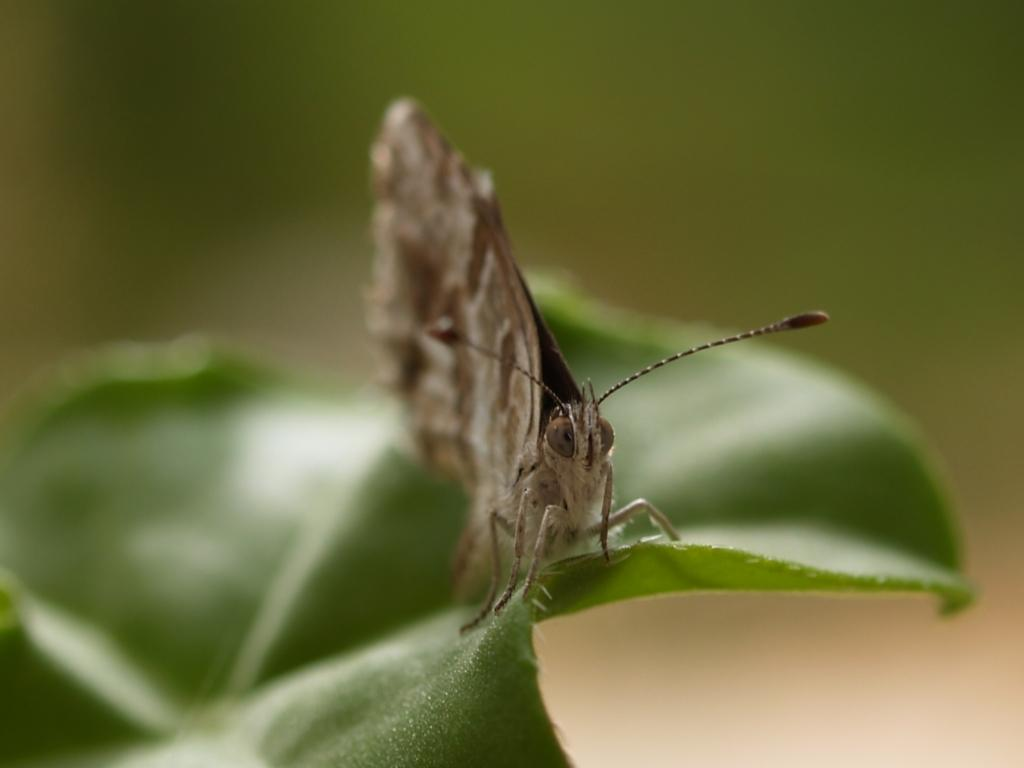What type of creature can be seen in the image? There is an insect in the image. Can you describe the color of the insect? The insect is brown and cream in color. Where is the insect located in the image? The insect is on a leaf. What is the color of the leaf? The leaf is green in color. How would you describe the background of the image? The background of the image is blurry. What is the rate of the insect's movement in the image? The rate of the insect's movement cannot be determined from the image, as it is a still photograph. --- Facts: 1. There is a person holding a book in the image. 2. The person is sitting on a chair. 3. The chair is made of wood. 4. The book has a blue cover. 5. There is a table next to the chair. Absurd Topics: animal, ocean, dance Conversation: What is the person in the image doing? The person is holding a book in the image. Where is the person sitting? The person is sitting on a chair. What is the chair made of? The chair is made of wood. What color is the book's cover? The book has a blue cover. What is located next to the chair? There is a table next to the chair. Reasoning: Let's think step by step in order to produce the conversation. We start by identifying the main subject in the image, which is the person holding a book. Then, we expand the conversation to include details about the person's location, the chair's material, the book's color, and the presence of a table. Each question is designed to elicit a specific detail about the image that is known from the provided facts. Absurd Question/Answer: Can you see any animals swimming in the ocean in the image? There is no ocean or animals present in the image; it features a person sitting on a wooden chair holding a book with a blue cover. 